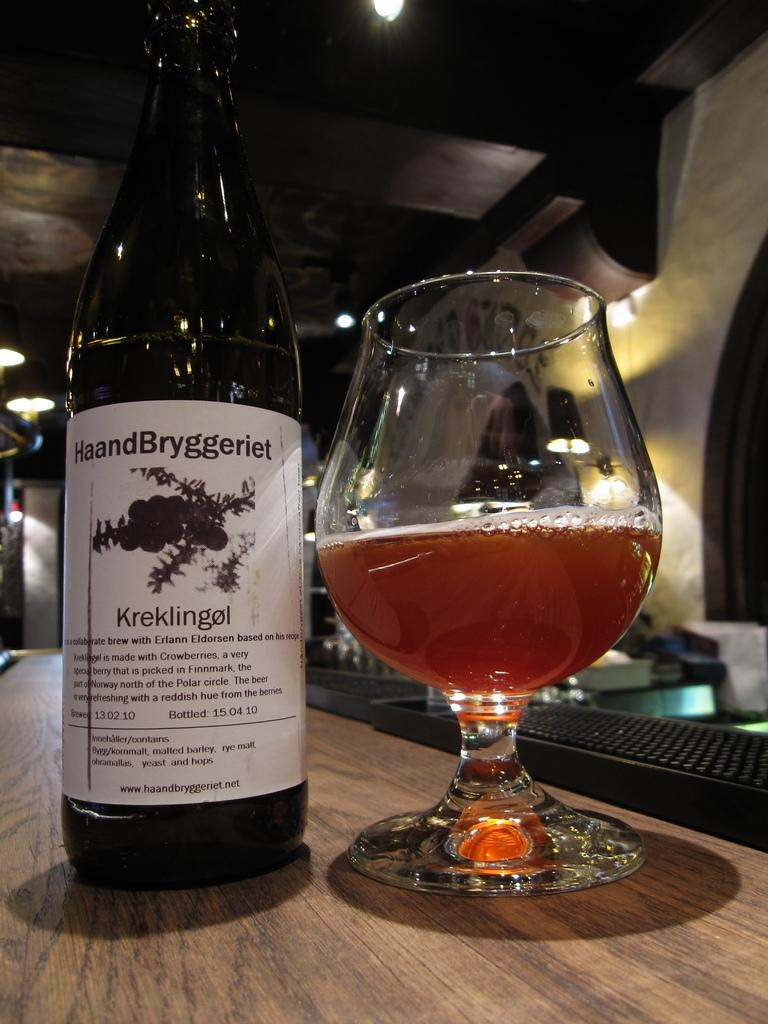What is on the bottle in the image? There is a sticker on the bottle in the image. What is in the glass in the image? There is a drink in the glass in the image. Where are the bottle and glass located? Both the bottle and the glass are on a table in the image. Can you describe any other objects on the table? There are other unspecified objects on the table in the image. What type of skin condition can be seen on the person in the image? There is no person present in the image, so it is not possible to determine if there is a skin condition or not. 